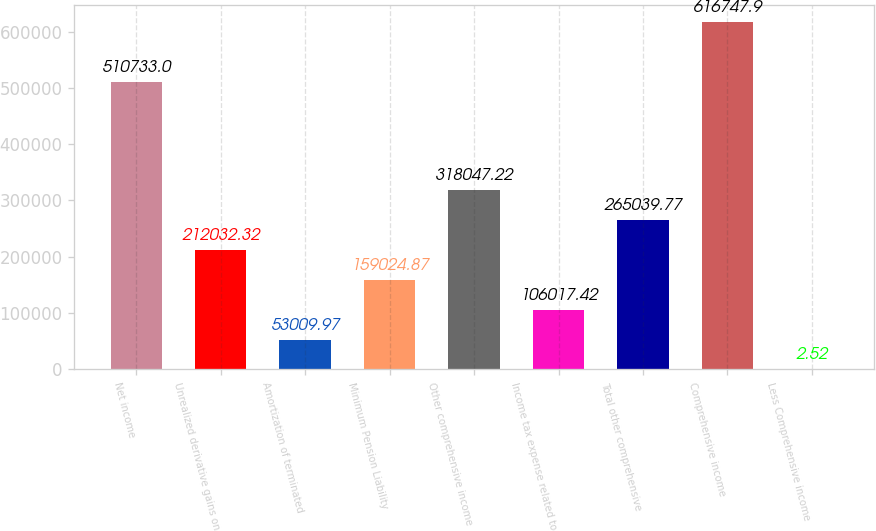<chart> <loc_0><loc_0><loc_500><loc_500><bar_chart><fcel>Net income<fcel>Unrealized derivative gains on<fcel>Amortization of terminated<fcel>Minimum Pension Liability<fcel>Other comprehensive income<fcel>Income tax expense related to<fcel>Total other comprehensive<fcel>Comprehensive income<fcel>Less Comprehensive income<nl><fcel>510733<fcel>212032<fcel>53010<fcel>159025<fcel>318047<fcel>106017<fcel>265040<fcel>616748<fcel>2.52<nl></chart> 